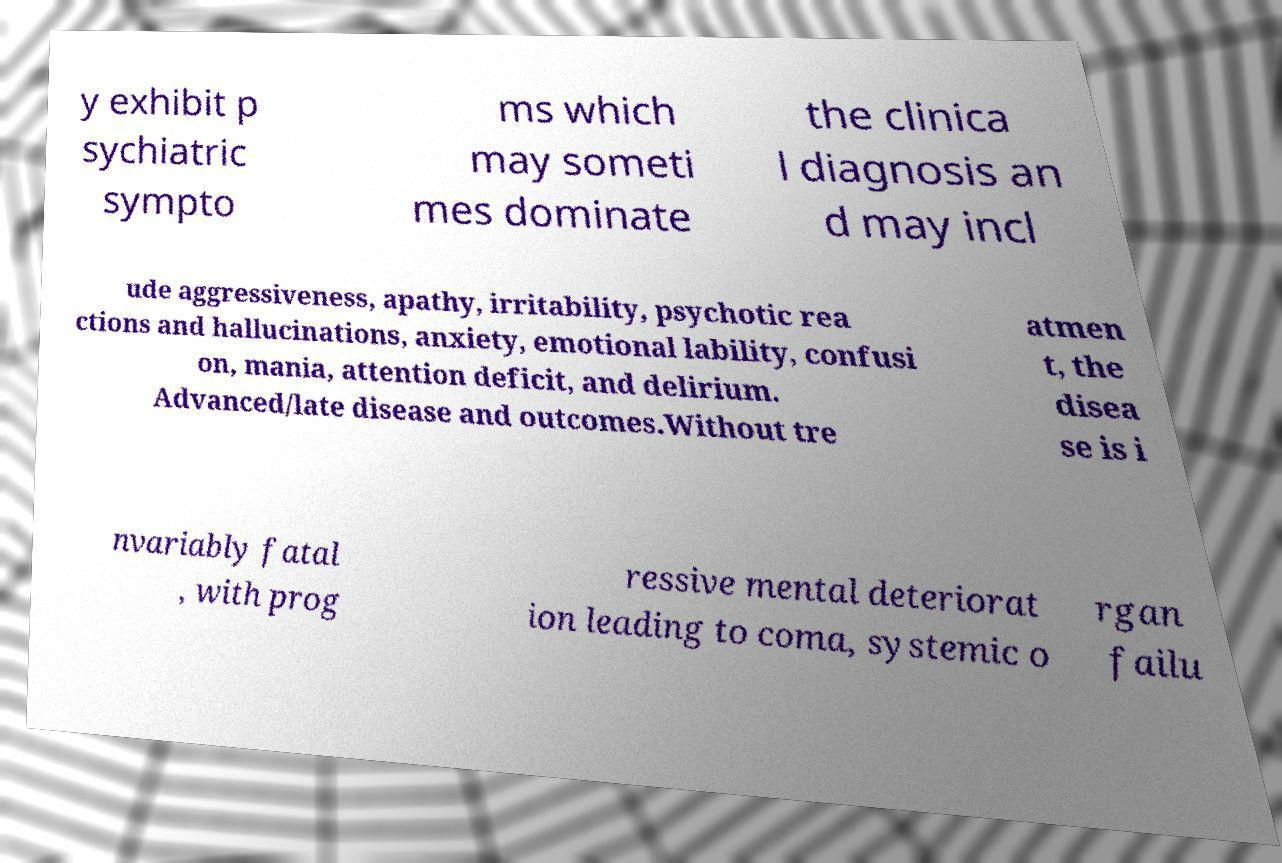Could you extract and type out the text from this image? y exhibit p sychiatric sympto ms which may someti mes dominate the clinica l diagnosis an d may incl ude aggressiveness, apathy, irritability, psychotic rea ctions and hallucinations, anxiety, emotional lability, confusi on, mania, attention deficit, and delirium. Advanced/late disease and outcomes.Without tre atmen t, the disea se is i nvariably fatal , with prog ressive mental deteriorat ion leading to coma, systemic o rgan failu 